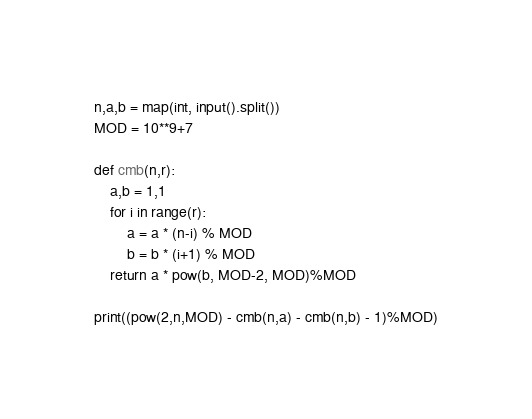<code> <loc_0><loc_0><loc_500><loc_500><_Python_>n,a,b = map(int, input().split())
MOD = 10**9+7

def cmb(n,r):
    a,b = 1,1
    for i in range(r):
        a = a * (n-i) % MOD
        b = b * (i+1) % MOD
    return a * pow(b, MOD-2, MOD)%MOD

print((pow(2,n,MOD) - cmb(n,a) - cmb(n,b) - 1)%MOD)</code> 